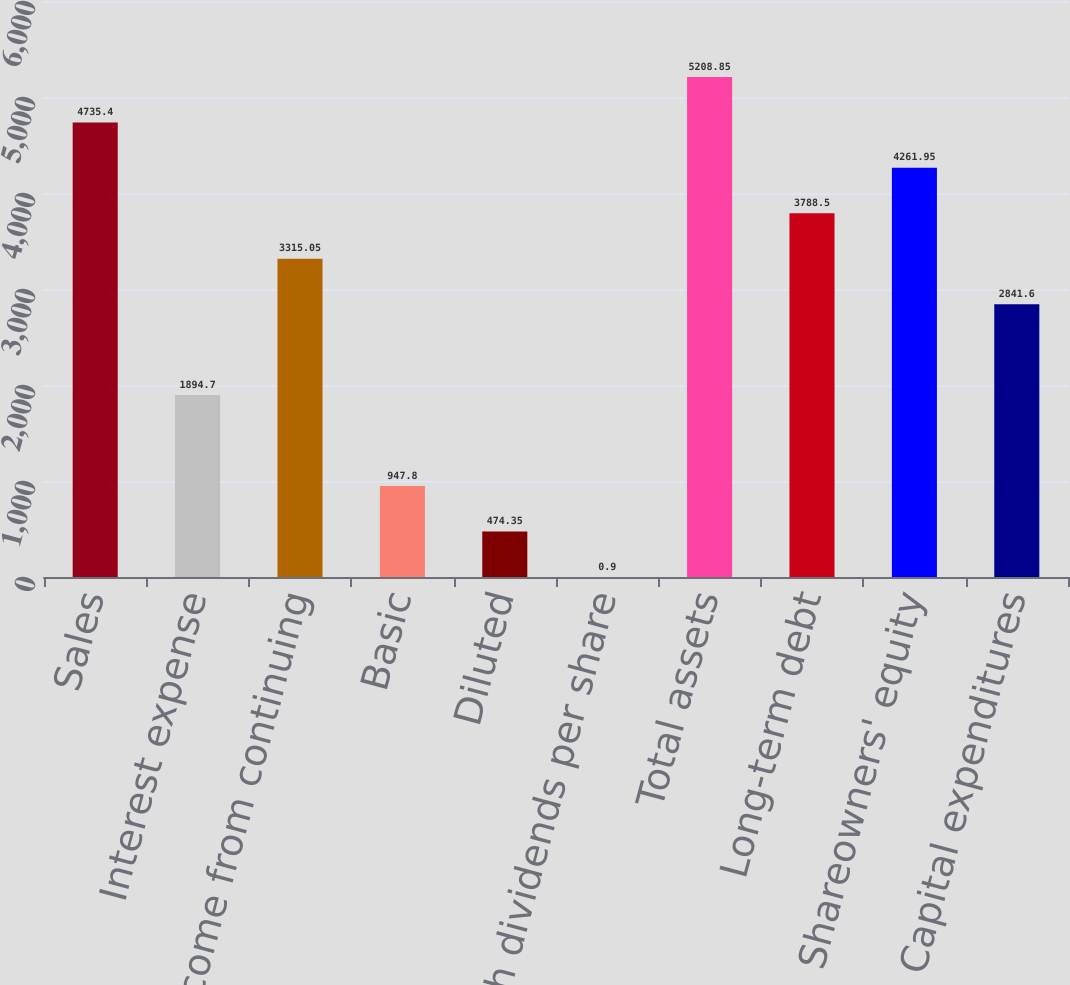<chart> <loc_0><loc_0><loc_500><loc_500><bar_chart><fcel>Sales<fcel>Interest expense<fcel>Income from continuing<fcel>Basic<fcel>Diluted<fcel>Cash dividends per share<fcel>Total assets<fcel>Long-term debt<fcel>Shareowners' equity<fcel>Capital expenditures<nl><fcel>4735.4<fcel>1894.7<fcel>3315.05<fcel>947.8<fcel>474.35<fcel>0.9<fcel>5208.85<fcel>3788.5<fcel>4261.95<fcel>2841.6<nl></chart> 